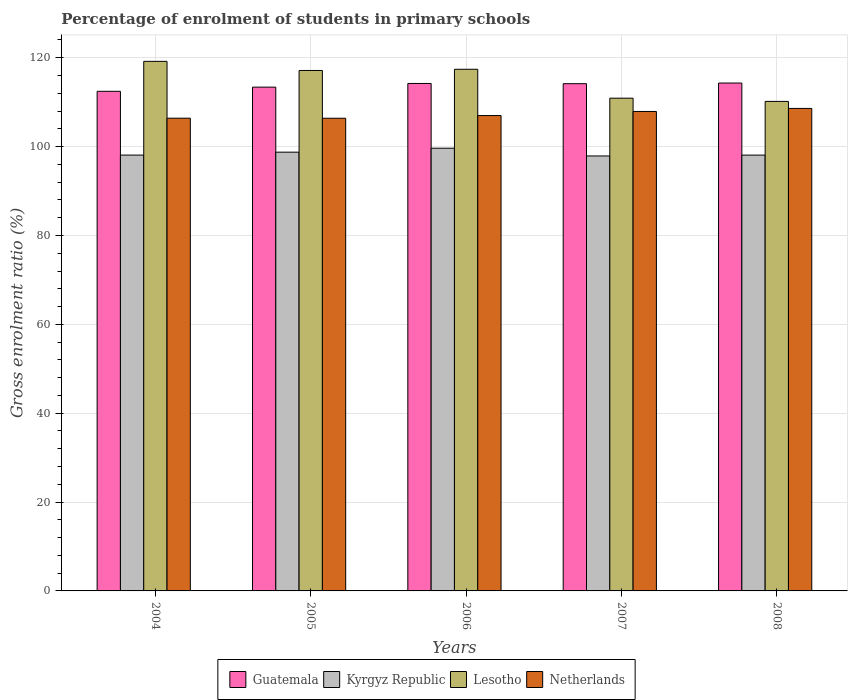How many different coloured bars are there?
Provide a short and direct response. 4. How many groups of bars are there?
Your response must be concise. 5. How many bars are there on the 4th tick from the right?
Your answer should be very brief. 4. What is the label of the 3rd group of bars from the left?
Make the answer very short. 2006. What is the percentage of students enrolled in primary schools in Lesotho in 2006?
Make the answer very short. 117.41. Across all years, what is the maximum percentage of students enrolled in primary schools in Netherlands?
Make the answer very short. 108.6. Across all years, what is the minimum percentage of students enrolled in primary schools in Kyrgyz Republic?
Offer a very short reply. 97.9. In which year was the percentage of students enrolled in primary schools in Lesotho minimum?
Your answer should be compact. 2008. What is the total percentage of students enrolled in primary schools in Netherlands in the graph?
Keep it short and to the point. 536.29. What is the difference between the percentage of students enrolled in primary schools in Lesotho in 2004 and that in 2008?
Keep it short and to the point. 9.01. What is the difference between the percentage of students enrolled in primary schools in Guatemala in 2007 and the percentage of students enrolled in primary schools in Lesotho in 2004?
Your response must be concise. -5.02. What is the average percentage of students enrolled in primary schools in Guatemala per year?
Your response must be concise. 113.71. In the year 2004, what is the difference between the percentage of students enrolled in primary schools in Lesotho and percentage of students enrolled in primary schools in Guatemala?
Your answer should be compact. 6.74. What is the ratio of the percentage of students enrolled in primary schools in Lesotho in 2007 to that in 2008?
Your answer should be very brief. 1.01. Is the difference between the percentage of students enrolled in primary schools in Lesotho in 2005 and 2008 greater than the difference between the percentage of students enrolled in primary schools in Guatemala in 2005 and 2008?
Offer a terse response. Yes. What is the difference between the highest and the second highest percentage of students enrolled in primary schools in Lesotho?
Your answer should be compact. 1.78. What is the difference between the highest and the lowest percentage of students enrolled in primary schools in Guatemala?
Provide a succinct answer. 1.86. Is it the case that in every year, the sum of the percentage of students enrolled in primary schools in Guatemala and percentage of students enrolled in primary schools in Netherlands is greater than the sum of percentage of students enrolled in primary schools in Lesotho and percentage of students enrolled in primary schools in Kyrgyz Republic?
Your response must be concise. No. What does the 1st bar from the left in 2007 represents?
Your response must be concise. Guatemala. What does the 2nd bar from the right in 2004 represents?
Ensure brevity in your answer.  Lesotho. Is it the case that in every year, the sum of the percentage of students enrolled in primary schools in Netherlands and percentage of students enrolled in primary schools in Guatemala is greater than the percentage of students enrolled in primary schools in Kyrgyz Republic?
Keep it short and to the point. Yes. Are all the bars in the graph horizontal?
Ensure brevity in your answer.  No. How many years are there in the graph?
Provide a succinct answer. 5. What is the difference between two consecutive major ticks on the Y-axis?
Provide a succinct answer. 20. Are the values on the major ticks of Y-axis written in scientific E-notation?
Offer a terse response. No. Does the graph contain any zero values?
Give a very brief answer. No. How many legend labels are there?
Offer a very short reply. 4. How are the legend labels stacked?
Offer a very short reply. Horizontal. What is the title of the graph?
Make the answer very short. Percentage of enrolment of students in primary schools. Does "New Zealand" appear as one of the legend labels in the graph?
Keep it short and to the point. No. What is the label or title of the X-axis?
Your response must be concise. Years. What is the Gross enrolment ratio (%) of Guatemala in 2004?
Keep it short and to the point. 112.45. What is the Gross enrolment ratio (%) of Kyrgyz Republic in 2004?
Keep it short and to the point. 98.09. What is the Gross enrolment ratio (%) in Lesotho in 2004?
Make the answer very short. 119.19. What is the Gross enrolment ratio (%) in Netherlands in 2004?
Your answer should be compact. 106.4. What is the Gross enrolment ratio (%) in Guatemala in 2005?
Make the answer very short. 113.39. What is the Gross enrolment ratio (%) of Kyrgyz Republic in 2005?
Give a very brief answer. 98.75. What is the Gross enrolment ratio (%) in Lesotho in 2005?
Your answer should be compact. 117.14. What is the Gross enrolment ratio (%) of Netherlands in 2005?
Your response must be concise. 106.39. What is the Gross enrolment ratio (%) in Guatemala in 2006?
Offer a very short reply. 114.22. What is the Gross enrolment ratio (%) of Kyrgyz Republic in 2006?
Offer a very short reply. 99.64. What is the Gross enrolment ratio (%) of Lesotho in 2006?
Offer a terse response. 117.41. What is the Gross enrolment ratio (%) of Netherlands in 2006?
Your answer should be very brief. 106.99. What is the Gross enrolment ratio (%) of Guatemala in 2007?
Provide a succinct answer. 114.17. What is the Gross enrolment ratio (%) in Kyrgyz Republic in 2007?
Provide a short and direct response. 97.9. What is the Gross enrolment ratio (%) of Lesotho in 2007?
Offer a terse response. 110.9. What is the Gross enrolment ratio (%) in Netherlands in 2007?
Give a very brief answer. 107.91. What is the Gross enrolment ratio (%) in Guatemala in 2008?
Your answer should be compact. 114.31. What is the Gross enrolment ratio (%) of Kyrgyz Republic in 2008?
Offer a very short reply. 98.09. What is the Gross enrolment ratio (%) in Lesotho in 2008?
Provide a succinct answer. 110.18. What is the Gross enrolment ratio (%) of Netherlands in 2008?
Offer a terse response. 108.6. Across all years, what is the maximum Gross enrolment ratio (%) in Guatemala?
Make the answer very short. 114.31. Across all years, what is the maximum Gross enrolment ratio (%) of Kyrgyz Republic?
Make the answer very short. 99.64. Across all years, what is the maximum Gross enrolment ratio (%) in Lesotho?
Make the answer very short. 119.19. Across all years, what is the maximum Gross enrolment ratio (%) of Netherlands?
Keep it short and to the point. 108.6. Across all years, what is the minimum Gross enrolment ratio (%) in Guatemala?
Provide a succinct answer. 112.45. Across all years, what is the minimum Gross enrolment ratio (%) in Kyrgyz Republic?
Your response must be concise. 97.9. Across all years, what is the minimum Gross enrolment ratio (%) of Lesotho?
Provide a short and direct response. 110.18. Across all years, what is the minimum Gross enrolment ratio (%) in Netherlands?
Your response must be concise. 106.39. What is the total Gross enrolment ratio (%) of Guatemala in the graph?
Make the answer very short. 568.53. What is the total Gross enrolment ratio (%) of Kyrgyz Republic in the graph?
Make the answer very short. 492.47. What is the total Gross enrolment ratio (%) of Lesotho in the graph?
Give a very brief answer. 574.82. What is the total Gross enrolment ratio (%) in Netherlands in the graph?
Offer a terse response. 536.29. What is the difference between the Gross enrolment ratio (%) of Guatemala in 2004 and that in 2005?
Your response must be concise. -0.94. What is the difference between the Gross enrolment ratio (%) of Kyrgyz Republic in 2004 and that in 2005?
Offer a terse response. -0.66. What is the difference between the Gross enrolment ratio (%) of Lesotho in 2004 and that in 2005?
Offer a very short reply. 2.05. What is the difference between the Gross enrolment ratio (%) in Netherlands in 2004 and that in 2005?
Offer a very short reply. 0.01. What is the difference between the Gross enrolment ratio (%) in Guatemala in 2004 and that in 2006?
Your response must be concise. -1.77. What is the difference between the Gross enrolment ratio (%) in Kyrgyz Republic in 2004 and that in 2006?
Provide a succinct answer. -1.55. What is the difference between the Gross enrolment ratio (%) of Lesotho in 2004 and that in 2006?
Provide a succinct answer. 1.78. What is the difference between the Gross enrolment ratio (%) of Netherlands in 2004 and that in 2006?
Your response must be concise. -0.6. What is the difference between the Gross enrolment ratio (%) in Guatemala in 2004 and that in 2007?
Your answer should be very brief. -1.72. What is the difference between the Gross enrolment ratio (%) in Kyrgyz Republic in 2004 and that in 2007?
Keep it short and to the point. 0.2. What is the difference between the Gross enrolment ratio (%) of Lesotho in 2004 and that in 2007?
Offer a terse response. 8.29. What is the difference between the Gross enrolment ratio (%) of Netherlands in 2004 and that in 2007?
Ensure brevity in your answer.  -1.52. What is the difference between the Gross enrolment ratio (%) in Guatemala in 2004 and that in 2008?
Make the answer very short. -1.86. What is the difference between the Gross enrolment ratio (%) in Kyrgyz Republic in 2004 and that in 2008?
Offer a very short reply. 0. What is the difference between the Gross enrolment ratio (%) of Lesotho in 2004 and that in 2008?
Make the answer very short. 9.01. What is the difference between the Gross enrolment ratio (%) in Netherlands in 2004 and that in 2008?
Provide a succinct answer. -2.2. What is the difference between the Gross enrolment ratio (%) of Guatemala in 2005 and that in 2006?
Your answer should be compact. -0.83. What is the difference between the Gross enrolment ratio (%) of Kyrgyz Republic in 2005 and that in 2006?
Offer a very short reply. -0.89. What is the difference between the Gross enrolment ratio (%) in Lesotho in 2005 and that in 2006?
Provide a short and direct response. -0.27. What is the difference between the Gross enrolment ratio (%) in Netherlands in 2005 and that in 2006?
Ensure brevity in your answer.  -0.6. What is the difference between the Gross enrolment ratio (%) in Guatemala in 2005 and that in 2007?
Ensure brevity in your answer.  -0.78. What is the difference between the Gross enrolment ratio (%) of Kyrgyz Republic in 2005 and that in 2007?
Make the answer very short. 0.86. What is the difference between the Gross enrolment ratio (%) in Lesotho in 2005 and that in 2007?
Ensure brevity in your answer.  6.23. What is the difference between the Gross enrolment ratio (%) in Netherlands in 2005 and that in 2007?
Make the answer very short. -1.53. What is the difference between the Gross enrolment ratio (%) of Guatemala in 2005 and that in 2008?
Your answer should be very brief. -0.92. What is the difference between the Gross enrolment ratio (%) of Kyrgyz Republic in 2005 and that in 2008?
Give a very brief answer. 0.66. What is the difference between the Gross enrolment ratio (%) of Lesotho in 2005 and that in 2008?
Your answer should be compact. 6.96. What is the difference between the Gross enrolment ratio (%) in Netherlands in 2005 and that in 2008?
Provide a short and direct response. -2.21. What is the difference between the Gross enrolment ratio (%) of Guatemala in 2006 and that in 2007?
Ensure brevity in your answer.  0.05. What is the difference between the Gross enrolment ratio (%) in Kyrgyz Republic in 2006 and that in 2007?
Your response must be concise. 1.74. What is the difference between the Gross enrolment ratio (%) in Lesotho in 2006 and that in 2007?
Give a very brief answer. 6.51. What is the difference between the Gross enrolment ratio (%) of Netherlands in 2006 and that in 2007?
Offer a terse response. -0.92. What is the difference between the Gross enrolment ratio (%) in Guatemala in 2006 and that in 2008?
Your answer should be very brief. -0.09. What is the difference between the Gross enrolment ratio (%) in Kyrgyz Republic in 2006 and that in 2008?
Provide a short and direct response. 1.55. What is the difference between the Gross enrolment ratio (%) in Lesotho in 2006 and that in 2008?
Offer a very short reply. 7.23. What is the difference between the Gross enrolment ratio (%) of Netherlands in 2006 and that in 2008?
Your response must be concise. -1.6. What is the difference between the Gross enrolment ratio (%) in Guatemala in 2007 and that in 2008?
Provide a succinct answer. -0.14. What is the difference between the Gross enrolment ratio (%) in Kyrgyz Republic in 2007 and that in 2008?
Keep it short and to the point. -0.2. What is the difference between the Gross enrolment ratio (%) of Lesotho in 2007 and that in 2008?
Keep it short and to the point. 0.73. What is the difference between the Gross enrolment ratio (%) of Netherlands in 2007 and that in 2008?
Your answer should be very brief. -0.68. What is the difference between the Gross enrolment ratio (%) of Guatemala in 2004 and the Gross enrolment ratio (%) of Kyrgyz Republic in 2005?
Your answer should be compact. 13.7. What is the difference between the Gross enrolment ratio (%) in Guatemala in 2004 and the Gross enrolment ratio (%) in Lesotho in 2005?
Offer a very short reply. -4.69. What is the difference between the Gross enrolment ratio (%) in Guatemala in 2004 and the Gross enrolment ratio (%) in Netherlands in 2005?
Make the answer very short. 6.06. What is the difference between the Gross enrolment ratio (%) in Kyrgyz Republic in 2004 and the Gross enrolment ratio (%) in Lesotho in 2005?
Your response must be concise. -19.04. What is the difference between the Gross enrolment ratio (%) in Kyrgyz Republic in 2004 and the Gross enrolment ratio (%) in Netherlands in 2005?
Provide a short and direct response. -8.29. What is the difference between the Gross enrolment ratio (%) of Lesotho in 2004 and the Gross enrolment ratio (%) of Netherlands in 2005?
Your response must be concise. 12.8. What is the difference between the Gross enrolment ratio (%) of Guatemala in 2004 and the Gross enrolment ratio (%) of Kyrgyz Republic in 2006?
Provide a succinct answer. 12.81. What is the difference between the Gross enrolment ratio (%) of Guatemala in 2004 and the Gross enrolment ratio (%) of Lesotho in 2006?
Your response must be concise. -4.96. What is the difference between the Gross enrolment ratio (%) in Guatemala in 2004 and the Gross enrolment ratio (%) in Netherlands in 2006?
Your answer should be compact. 5.46. What is the difference between the Gross enrolment ratio (%) of Kyrgyz Republic in 2004 and the Gross enrolment ratio (%) of Lesotho in 2006?
Your response must be concise. -19.32. What is the difference between the Gross enrolment ratio (%) in Kyrgyz Republic in 2004 and the Gross enrolment ratio (%) in Netherlands in 2006?
Offer a very short reply. -8.9. What is the difference between the Gross enrolment ratio (%) of Lesotho in 2004 and the Gross enrolment ratio (%) of Netherlands in 2006?
Make the answer very short. 12.2. What is the difference between the Gross enrolment ratio (%) in Guatemala in 2004 and the Gross enrolment ratio (%) in Kyrgyz Republic in 2007?
Provide a short and direct response. 14.55. What is the difference between the Gross enrolment ratio (%) of Guatemala in 2004 and the Gross enrolment ratio (%) of Lesotho in 2007?
Your answer should be very brief. 1.55. What is the difference between the Gross enrolment ratio (%) of Guatemala in 2004 and the Gross enrolment ratio (%) of Netherlands in 2007?
Your answer should be compact. 4.54. What is the difference between the Gross enrolment ratio (%) of Kyrgyz Republic in 2004 and the Gross enrolment ratio (%) of Lesotho in 2007?
Your answer should be compact. -12.81. What is the difference between the Gross enrolment ratio (%) of Kyrgyz Republic in 2004 and the Gross enrolment ratio (%) of Netherlands in 2007?
Your answer should be very brief. -9.82. What is the difference between the Gross enrolment ratio (%) of Lesotho in 2004 and the Gross enrolment ratio (%) of Netherlands in 2007?
Your answer should be very brief. 11.28. What is the difference between the Gross enrolment ratio (%) in Guatemala in 2004 and the Gross enrolment ratio (%) in Kyrgyz Republic in 2008?
Offer a very short reply. 14.36. What is the difference between the Gross enrolment ratio (%) of Guatemala in 2004 and the Gross enrolment ratio (%) of Lesotho in 2008?
Make the answer very short. 2.27. What is the difference between the Gross enrolment ratio (%) in Guatemala in 2004 and the Gross enrolment ratio (%) in Netherlands in 2008?
Your response must be concise. 3.85. What is the difference between the Gross enrolment ratio (%) of Kyrgyz Republic in 2004 and the Gross enrolment ratio (%) of Lesotho in 2008?
Provide a short and direct response. -12.08. What is the difference between the Gross enrolment ratio (%) of Kyrgyz Republic in 2004 and the Gross enrolment ratio (%) of Netherlands in 2008?
Your answer should be compact. -10.5. What is the difference between the Gross enrolment ratio (%) of Lesotho in 2004 and the Gross enrolment ratio (%) of Netherlands in 2008?
Offer a very short reply. 10.6. What is the difference between the Gross enrolment ratio (%) of Guatemala in 2005 and the Gross enrolment ratio (%) of Kyrgyz Republic in 2006?
Make the answer very short. 13.75. What is the difference between the Gross enrolment ratio (%) of Guatemala in 2005 and the Gross enrolment ratio (%) of Lesotho in 2006?
Your answer should be very brief. -4.02. What is the difference between the Gross enrolment ratio (%) in Guatemala in 2005 and the Gross enrolment ratio (%) in Netherlands in 2006?
Ensure brevity in your answer.  6.4. What is the difference between the Gross enrolment ratio (%) of Kyrgyz Republic in 2005 and the Gross enrolment ratio (%) of Lesotho in 2006?
Make the answer very short. -18.66. What is the difference between the Gross enrolment ratio (%) of Kyrgyz Republic in 2005 and the Gross enrolment ratio (%) of Netherlands in 2006?
Your answer should be compact. -8.24. What is the difference between the Gross enrolment ratio (%) in Lesotho in 2005 and the Gross enrolment ratio (%) in Netherlands in 2006?
Offer a very short reply. 10.15. What is the difference between the Gross enrolment ratio (%) of Guatemala in 2005 and the Gross enrolment ratio (%) of Kyrgyz Republic in 2007?
Ensure brevity in your answer.  15.49. What is the difference between the Gross enrolment ratio (%) of Guatemala in 2005 and the Gross enrolment ratio (%) of Lesotho in 2007?
Ensure brevity in your answer.  2.48. What is the difference between the Gross enrolment ratio (%) of Guatemala in 2005 and the Gross enrolment ratio (%) of Netherlands in 2007?
Make the answer very short. 5.47. What is the difference between the Gross enrolment ratio (%) in Kyrgyz Republic in 2005 and the Gross enrolment ratio (%) in Lesotho in 2007?
Ensure brevity in your answer.  -12.15. What is the difference between the Gross enrolment ratio (%) in Kyrgyz Republic in 2005 and the Gross enrolment ratio (%) in Netherlands in 2007?
Give a very brief answer. -9.16. What is the difference between the Gross enrolment ratio (%) of Lesotho in 2005 and the Gross enrolment ratio (%) of Netherlands in 2007?
Make the answer very short. 9.22. What is the difference between the Gross enrolment ratio (%) of Guatemala in 2005 and the Gross enrolment ratio (%) of Kyrgyz Republic in 2008?
Your response must be concise. 15.3. What is the difference between the Gross enrolment ratio (%) in Guatemala in 2005 and the Gross enrolment ratio (%) in Lesotho in 2008?
Your answer should be compact. 3.21. What is the difference between the Gross enrolment ratio (%) of Guatemala in 2005 and the Gross enrolment ratio (%) of Netherlands in 2008?
Give a very brief answer. 4.79. What is the difference between the Gross enrolment ratio (%) in Kyrgyz Republic in 2005 and the Gross enrolment ratio (%) in Lesotho in 2008?
Keep it short and to the point. -11.42. What is the difference between the Gross enrolment ratio (%) of Kyrgyz Republic in 2005 and the Gross enrolment ratio (%) of Netherlands in 2008?
Make the answer very short. -9.84. What is the difference between the Gross enrolment ratio (%) of Lesotho in 2005 and the Gross enrolment ratio (%) of Netherlands in 2008?
Your response must be concise. 8.54. What is the difference between the Gross enrolment ratio (%) of Guatemala in 2006 and the Gross enrolment ratio (%) of Kyrgyz Republic in 2007?
Provide a succinct answer. 16.32. What is the difference between the Gross enrolment ratio (%) of Guatemala in 2006 and the Gross enrolment ratio (%) of Lesotho in 2007?
Ensure brevity in your answer.  3.31. What is the difference between the Gross enrolment ratio (%) in Guatemala in 2006 and the Gross enrolment ratio (%) in Netherlands in 2007?
Your response must be concise. 6.3. What is the difference between the Gross enrolment ratio (%) in Kyrgyz Republic in 2006 and the Gross enrolment ratio (%) in Lesotho in 2007?
Provide a short and direct response. -11.26. What is the difference between the Gross enrolment ratio (%) of Kyrgyz Republic in 2006 and the Gross enrolment ratio (%) of Netherlands in 2007?
Your answer should be very brief. -8.27. What is the difference between the Gross enrolment ratio (%) of Lesotho in 2006 and the Gross enrolment ratio (%) of Netherlands in 2007?
Your response must be concise. 9.5. What is the difference between the Gross enrolment ratio (%) of Guatemala in 2006 and the Gross enrolment ratio (%) of Kyrgyz Republic in 2008?
Provide a succinct answer. 16.12. What is the difference between the Gross enrolment ratio (%) of Guatemala in 2006 and the Gross enrolment ratio (%) of Lesotho in 2008?
Your answer should be compact. 4.04. What is the difference between the Gross enrolment ratio (%) of Guatemala in 2006 and the Gross enrolment ratio (%) of Netherlands in 2008?
Offer a very short reply. 5.62. What is the difference between the Gross enrolment ratio (%) in Kyrgyz Republic in 2006 and the Gross enrolment ratio (%) in Lesotho in 2008?
Offer a very short reply. -10.54. What is the difference between the Gross enrolment ratio (%) in Kyrgyz Republic in 2006 and the Gross enrolment ratio (%) in Netherlands in 2008?
Offer a terse response. -8.96. What is the difference between the Gross enrolment ratio (%) in Lesotho in 2006 and the Gross enrolment ratio (%) in Netherlands in 2008?
Offer a terse response. 8.81. What is the difference between the Gross enrolment ratio (%) in Guatemala in 2007 and the Gross enrolment ratio (%) in Kyrgyz Republic in 2008?
Offer a very short reply. 16.08. What is the difference between the Gross enrolment ratio (%) of Guatemala in 2007 and the Gross enrolment ratio (%) of Lesotho in 2008?
Provide a succinct answer. 3.99. What is the difference between the Gross enrolment ratio (%) in Guatemala in 2007 and the Gross enrolment ratio (%) in Netherlands in 2008?
Give a very brief answer. 5.57. What is the difference between the Gross enrolment ratio (%) in Kyrgyz Republic in 2007 and the Gross enrolment ratio (%) in Lesotho in 2008?
Provide a short and direct response. -12.28. What is the difference between the Gross enrolment ratio (%) of Kyrgyz Republic in 2007 and the Gross enrolment ratio (%) of Netherlands in 2008?
Provide a succinct answer. -10.7. What is the difference between the Gross enrolment ratio (%) in Lesotho in 2007 and the Gross enrolment ratio (%) in Netherlands in 2008?
Keep it short and to the point. 2.31. What is the average Gross enrolment ratio (%) of Guatemala per year?
Ensure brevity in your answer.  113.71. What is the average Gross enrolment ratio (%) of Kyrgyz Republic per year?
Give a very brief answer. 98.49. What is the average Gross enrolment ratio (%) of Lesotho per year?
Ensure brevity in your answer.  114.96. What is the average Gross enrolment ratio (%) of Netherlands per year?
Give a very brief answer. 107.26. In the year 2004, what is the difference between the Gross enrolment ratio (%) in Guatemala and Gross enrolment ratio (%) in Kyrgyz Republic?
Offer a terse response. 14.36. In the year 2004, what is the difference between the Gross enrolment ratio (%) in Guatemala and Gross enrolment ratio (%) in Lesotho?
Your response must be concise. -6.74. In the year 2004, what is the difference between the Gross enrolment ratio (%) of Guatemala and Gross enrolment ratio (%) of Netherlands?
Ensure brevity in your answer.  6.05. In the year 2004, what is the difference between the Gross enrolment ratio (%) of Kyrgyz Republic and Gross enrolment ratio (%) of Lesotho?
Ensure brevity in your answer.  -21.1. In the year 2004, what is the difference between the Gross enrolment ratio (%) in Kyrgyz Republic and Gross enrolment ratio (%) in Netherlands?
Provide a short and direct response. -8.3. In the year 2004, what is the difference between the Gross enrolment ratio (%) in Lesotho and Gross enrolment ratio (%) in Netherlands?
Your response must be concise. 12.79. In the year 2005, what is the difference between the Gross enrolment ratio (%) of Guatemala and Gross enrolment ratio (%) of Kyrgyz Republic?
Offer a terse response. 14.64. In the year 2005, what is the difference between the Gross enrolment ratio (%) in Guatemala and Gross enrolment ratio (%) in Lesotho?
Make the answer very short. -3.75. In the year 2005, what is the difference between the Gross enrolment ratio (%) of Guatemala and Gross enrolment ratio (%) of Netherlands?
Give a very brief answer. 7. In the year 2005, what is the difference between the Gross enrolment ratio (%) of Kyrgyz Republic and Gross enrolment ratio (%) of Lesotho?
Provide a succinct answer. -18.38. In the year 2005, what is the difference between the Gross enrolment ratio (%) of Kyrgyz Republic and Gross enrolment ratio (%) of Netherlands?
Your answer should be compact. -7.63. In the year 2005, what is the difference between the Gross enrolment ratio (%) of Lesotho and Gross enrolment ratio (%) of Netherlands?
Offer a very short reply. 10.75. In the year 2006, what is the difference between the Gross enrolment ratio (%) of Guatemala and Gross enrolment ratio (%) of Kyrgyz Republic?
Offer a very short reply. 14.58. In the year 2006, what is the difference between the Gross enrolment ratio (%) in Guatemala and Gross enrolment ratio (%) in Lesotho?
Provide a succinct answer. -3.19. In the year 2006, what is the difference between the Gross enrolment ratio (%) of Guatemala and Gross enrolment ratio (%) of Netherlands?
Ensure brevity in your answer.  7.22. In the year 2006, what is the difference between the Gross enrolment ratio (%) of Kyrgyz Republic and Gross enrolment ratio (%) of Lesotho?
Your answer should be compact. -17.77. In the year 2006, what is the difference between the Gross enrolment ratio (%) in Kyrgyz Republic and Gross enrolment ratio (%) in Netherlands?
Provide a succinct answer. -7.35. In the year 2006, what is the difference between the Gross enrolment ratio (%) in Lesotho and Gross enrolment ratio (%) in Netherlands?
Your answer should be very brief. 10.42. In the year 2007, what is the difference between the Gross enrolment ratio (%) in Guatemala and Gross enrolment ratio (%) in Kyrgyz Republic?
Your answer should be compact. 16.27. In the year 2007, what is the difference between the Gross enrolment ratio (%) in Guatemala and Gross enrolment ratio (%) in Lesotho?
Give a very brief answer. 3.26. In the year 2007, what is the difference between the Gross enrolment ratio (%) in Guatemala and Gross enrolment ratio (%) in Netherlands?
Your response must be concise. 6.25. In the year 2007, what is the difference between the Gross enrolment ratio (%) in Kyrgyz Republic and Gross enrolment ratio (%) in Lesotho?
Provide a short and direct response. -13.01. In the year 2007, what is the difference between the Gross enrolment ratio (%) of Kyrgyz Republic and Gross enrolment ratio (%) of Netherlands?
Give a very brief answer. -10.02. In the year 2007, what is the difference between the Gross enrolment ratio (%) in Lesotho and Gross enrolment ratio (%) in Netherlands?
Your answer should be very brief. 2.99. In the year 2008, what is the difference between the Gross enrolment ratio (%) of Guatemala and Gross enrolment ratio (%) of Kyrgyz Republic?
Make the answer very short. 16.22. In the year 2008, what is the difference between the Gross enrolment ratio (%) of Guatemala and Gross enrolment ratio (%) of Lesotho?
Your answer should be very brief. 4.13. In the year 2008, what is the difference between the Gross enrolment ratio (%) of Guatemala and Gross enrolment ratio (%) of Netherlands?
Your response must be concise. 5.72. In the year 2008, what is the difference between the Gross enrolment ratio (%) of Kyrgyz Republic and Gross enrolment ratio (%) of Lesotho?
Keep it short and to the point. -12.09. In the year 2008, what is the difference between the Gross enrolment ratio (%) of Kyrgyz Republic and Gross enrolment ratio (%) of Netherlands?
Your answer should be compact. -10.5. In the year 2008, what is the difference between the Gross enrolment ratio (%) of Lesotho and Gross enrolment ratio (%) of Netherlands?
Your response must be concise. 1.58. What is the ratio of the Gross enrolment ratio (%) in Guatemala in 2004 to that in 2005?
Your answer should be very brief. 0.99. What is the ratio of the Gross enrolment ratio (%) in Kyrgyz Republic in 2004 to that in 2005?
Provide a succinct answer. 0.99. What is the ratio of the Gross enrolment ratio (%) of Lesotho in 2004 to that in 2005?
Your answer should be compact. 1.02. What is the ratio of the Gross enrolment ratio (%) of Guatemala in 2004 to that in 2006?
Offer a terse response. 0.98. What is the ratio of the Gross enrolment ratio (%) in Kyrgyz Republic in 2004 to that in 2006?
Keep it short and to the point. 0.98. What is the ratio of the Gross enrolment ratio (%) of Lesotho in 2004 to that in 2006?
Offer a very short reply. 1.02. What is the ratio of the Gross enrolment ratio (%) of Guatemala in 2004 to that in 2007?
Give a very brief answer. 0.98. What is the ratio of the Gross enrolment ratio (%) of Lesotho in 2004 to that in 2007?
Your answer should be very brief. 1.07. What is the ratio of the Gross enrolment ratio (%) of Netherlands in 2004 to that in 2007?
Provide a short and direct response. 0.99. What is the ratio of the Gross enrolment ratio (%) of Guatemala in 2004 to that in 2008?
Provide a short and direct response. 0.98. What is the ratio of the Gross enrolment ratio (%) of Lesotho in 2004 to that in 2008?
Offer a terse response. 1.08. What is the ratio of the Gross enrolment ratio (%) in Netherlands in 2004 to that in 2008?
Give a very brief answer. 0.98. What is the ratio of the Gross enrolment ratio (%) in Kyrgyz Republic in 2005 to that in 2006?
Provide a short and direct response. 0.99. What is the ratio of the Gross enrolment ratio (%) in Kyrgyz Republic in 2005 to that in 2007?
Your answer should be compact. 1.01. What is the ratio of the Gross enrolment ratio (%) in Lesotho in 2005 to that in 2007?
Offer a terse response. 1.06. What is the ratio of the Gross enrolment ratio (%) of Netherlands in 2005 to that in 2007?
Ensure brevity in your answer.  0.99. What is the ratio of the Gross enrolment ratio (%) in Lesotho in 2005 to that in 2008?
Your answer should be compact. 1.06. What is the ratio of the Gross enrolment ratio (%) in Netherlands in 2005 to that in 2008?
Provide a short and direct response. 0.98. What is the ratio of the Gross enrolment ratio (%) in Guatemala in 2006 to that in 2007?
Provide a succinct answer. 1. What is the ratio of the Gross enrolment ratio (%) in Kyrgyz Republic in 2006 to that in 2007?
Offer a terse response. 1.02. What is the ratio of the Gross enrolment ratio (%) in Lesotho in 2006 to that in 2007?
Ensure brevity in your answer.  1.06. What is the ratio of the Gross enrolment ratio (%) in Guatemala in 2006 to that in 2008?
Your answer should be very brief. 1. What is the ratio of the Gross enrolment ratio (%) of Kyrgyz Republic in 2006 to that in 2008?
Offer a terse response. 1.02. What is the ratio of the Gross enrolment ratio (%) of Lesotho in 2006 to that in 2008?
Give a very brief answer. 1.07. What is the ratio of the Gross enrolment ratio (%) of Netherlands in 2006 to that in 2008?
Provide a succinct answer. 0.99. What is the ratio of the Gross enrolment ratio (%) in Kyrgyz Republic in 2007 to that in 2008?
Give a very brief answer. 1. What is the ratio of the Gross enrolment ratio (%) of Lesotho in 2007 to that in 2008?
Offer a terse response. 1.01. What is the ratio of the Gross enrolment ratio (%) of Netherlands in 2007 to that in 2008?
Your answer should be compact. 0.99. What is the difference between the highest and the second highest Gross enrolment ratio (%) of Guatemala?
Make the answer very short. 0.09. What is the difference between the highest and the second highest Gross enrolment ratio (%) in Kyrgyz Republic?
Provide a short and direct response. 0.89. What is the difference between the highest and the second highest Gross enrolment ratio (%) in Lesotho?
Make the answer very short. 1.78. What is the difference between the highest and the second highest Gross enrolment ratio (%) in Netherlands?
Make the answer very short. 0.68. What is the difference between the highest and the lowest Gross enrolment ratio (%) in Guatemala?
Provide a short and direct response. 1.86. What is the difference between the highest and the lowest Gross enrolment ratio (%) in Kyrgyz Republic?
Provide a succinct answer. 1.74. What is the difference between the highest and the lowest Gross enrolment ratio (%) in Lesotho?
Make the answer very short. 9.01. What is the difference between the highest and the lowest Gross enrolment ratio (%) in Netherlands?
Offer a very short reply. 2.21. 